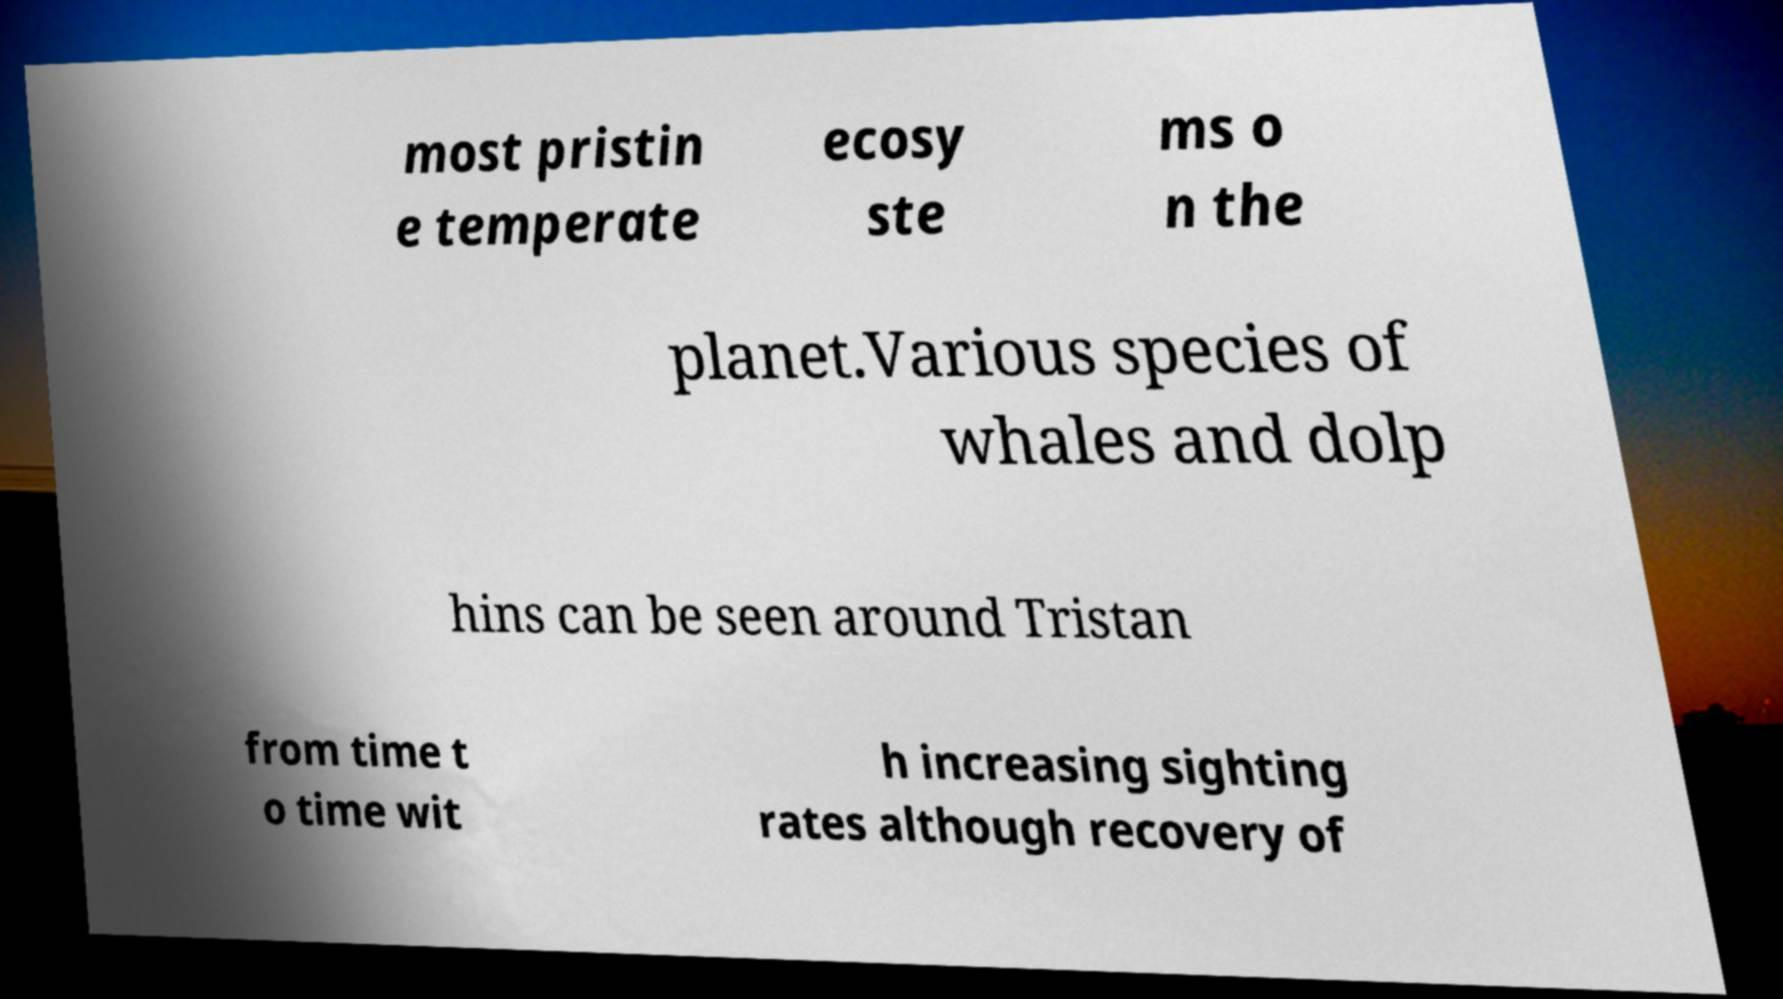Please identify and transcribe the text found in this image. most pristin e temperate ecosy ste ms o n the planet.Various species of whales and dolp hins can be seen around Tristan from time t o time wit h increasing sighting rates although recovery of 